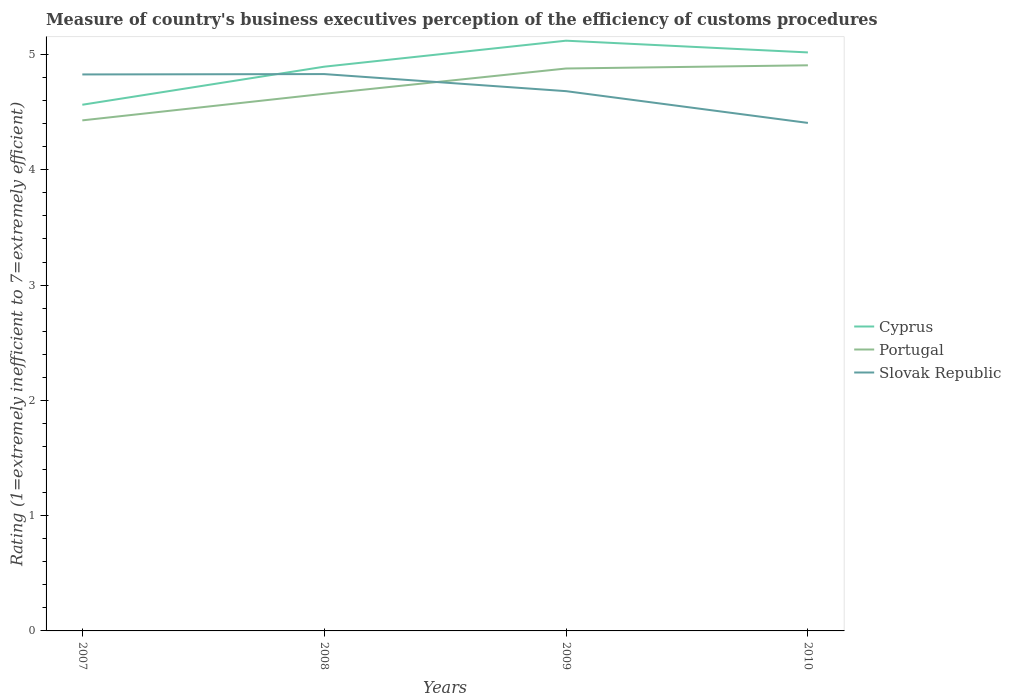How many different coloured lines are there?
Provide a short and direct response. 3. Does the line corresponding to Slovak Republic intersect with the line corresponding to Cyprus?
Your answer should be very brief. Yes. Is the number of lines equal to the number of legend labels?
Ensure brevity in your answer.  Yes. Across all years, what is the maximum rating of the efficiency of customs procedure in Cyprus?
Your answer should be compact. 4.56. In which year was the rating of the efficiency of customs procedure in Portugal maximum?
Ensure brevity in your answer.  2007. What is the total rating of the efficiency of customs procedure in Portugal in the graph?
Ensure brevity in your answer.  -0.45. What is the difference between the highest and the second highest rating of the efficiency of customs procedure in Portugal?
Offer a terse response. 0.48. How many lines are there?
Give a very brief answer. 3. How many years are there in the graph?
Your response must be concise. 4. What is the difference between two consecutive major ticks on the Y-axis?
Provide a short and direct response. 1. Does the graph contain any zero values?
Give a very brief answer. No. Does the graph contain grids?
Offer a very short reply. No. Where does the legend appear in the graph?
Your answer should be very brief. Center right. How many legend labels are there?
Provide a short and direct response. 3. What is the title of the graph?
Your answer should be compact. Measure of country's business executives perception of the efficiency of customs procedures. What is the label or title of the X-axis?
Your answer should be very brief. Years. What is the label or title of the Y-axis?
Provide a short and direct response. Rating (1=extremely inefficient to 7=extremely efficient). What is the Rating (1=extremely inefficient to 7=extremely efficient) in Cyprus in 2007?
Your answer should be very brief. 4.56. What is the Rating (1=extremely inefficient to 7=extremely efficient) of Portugal in 2007?
Your response must be concise. 4.43. What is the Rating (1=extremely inefficient to 7=extremely efficient) of Slovak Republic in 2007?
Provide a short and direct response. 4.83. What is the Rating (1=extremely inefficient to 7=extremely efficient) of Cyprus in 2008?
Ensure brevity in your answer.  4.89. What is the Rating (1=extremely inefficient to 7=extremely efficient) of Portugal in 2008?
Offer a very short reply. 4.66. What is the Rating (1=extremely inefficient to 7=extremely efficient) in Slovak Republic in 2008?
Give a very brief answer. 4.83. What is the Rating (1=extremely inefficient to 7=extremely efficient) of Cyprus in 2009?
Provide a short and direct response. 5.12. What is the Rating (1=extremely inefficient to 7=extremely efficient) of Portugal in 2009?
Offer a terse response. 4.88. What is the Rating (1=extremely inefficient to 7=extremely efficient) in Slovak Republic in 2009?
Make the answer very short. 4.68. What is the Rating (1=extremely inefficient to 7=extremely efficient) in Cyprus in 2010?
Your answer should be very brief. 5.02. What is the Rating (1=extremely inefficient to 7=extremely efficient) of Portugal in 2010?
Make the answer very short. 4.91. What is the Rating (1=extremely inefficient to 7=extremely efficient) of Slovak Republic in 2010?
Provide a succinct answer. 4.41. Across all years, what is the maximum Rating (1=extremely inefficient to 7=extremely efficient) in Cyprus?
Your answer should be very brief. 5.12. Across all years, what is the maximum Rating (1=extremely inefficient to 7=extremely efficient) in Portugal?
Your answer should be compact. 4.91. Across all years, what is the maximum Rating (1=extremely inefficient to 7=extremely efficient) in Slovak Republic?
Make the answer very short. 4.83. Across all years, what is the minimum Rating (1=extremely inefficient to 7=extremely efficient) of Cyprus?
Offer a very short reply. 4.56. Across all years, what is the minimum Rating (1=extremely inefficient to 7=extremely efficient) in Portugal?
Keep it short and to the point. 4.43. Across all years, what is the minimum Rating (1=extremely inefficient to 7=extremely efficient) in Slovak Republic?
Provide a short and direct response. 4.41. What is the total Rating (1=extremely inefficient to 7=extremely efficient) in Cyprus in the graph?
Provide a short and direct response. 19.6. What is the total Rating (1=extremely inefficient to 7=extremely efficient) of Portugal in the graph?
Give a very brief answer. 18.87. What is the total Rating (1=extremely inefficient to 7=extremely efficient) in Slovak Republic in the graph?
Give a very brief answer. 18.75. What is the difference between the Rating (1=extremely inefficient to 7=extremely efficient) of Cyprus in 2007 and that in 2008?
Your answer should be compact. -0.33. What is the difference between the Rating (1=extremely inefficient to 7=extremely efficient) in Portugal in 2007 and that in 2008?
Your answer should be compact. -0.23. What is the difference between the Rating (1=extremely inefficient to 7=extremely efficient) of Slovak Republic in 2007 and that in 2008?
Offer a terse response. -0. What is the difference between the Rating (1=extremely inefficient to 7=extremely efficient) of Cyprus in 2007 and that in 2009?
Provide a short and direct response. -0.56. What is the difference between the Rating (1=extremely inefficient to 7=extremely efficient) in Portugal in 2007 and that in 2009?
Provide a succinct answer. -0.45. What is the difference between the Rating (1=extremely inefficient to 7=extremely efficient) in Slovak Republic in 2007 and that in 2009?
Your response must be concise. 0.14. What is the difference between the Rating (1=extremely inefficient to 7=extremely efficient) in Cyprus in 2007 and that in 2010?
Your answer should be very brief. -0.45. What is the difference between the Rating (1=extremely inefficient to 7=extremely efficient) of Portugal in 2007 and that in 2010?
Offer a very short reply. -0.48. What is the difference between the Rating (1=extremely inefficient to 7=extremely efficient) in Slovak Republic in 2007 and that in 2010?
Your answer should be compact. 0.42. What is the difference between the Rating (1=extremely inefficient to 7=extremely efficient) of Cyprus in 2008 and that in 2009?
Give a very brief answer. -0.23. What is the difference between the Rating (1=extremely inefficient to 7=extremely efficient) of Portugal in 2008 and that in 2009?
Your answer should be compact. -0.22. What is the difference between the Rating (1=extremely inefficient to 7=extremely efficient) of Slovak Republic in 2008 and that in 2009?
Provide a succinct answer. 0.15. What is the difference between the Rating (1=extremely inefficient to 7=extremely efficient) in Cyprus in 2008 and that in 2010?
Offer a terse response. -0.12. What is the difference between the Rating (1=extremely inefficient to 7=extremely efficient) in Portugal in 2008 and that in 2010?
Offer a terse response. -0.25. What is the difference between the Rating (1=extremely inefficient to 7=extremely efficient) of Slovak Republic in 2008 and that in 2010?
Provide a short and direct response. 0.42. What is the difference between the Rating (1=extremely inefficient to 7=extremely efficient) in Cyprus in 2009 and that in 2010?
Your answer should be very brief. 0.1. What is the difference between the Rating (1=extremely inefficient to 7=extremely efficient) of Portugal in 2009 and that in 2010?
Give a very brief answer. -0.03. What is the difference between the Rating (1=extremely inefficient to 7=extremely efficient) of Slovak Republic in 2009 and that in 2010?
Ensure brevity in your answer.  0.28. What is the difference between the Rating (1=extremely inefficient to 7=extremely efficient) in Cyprus in 2007 and the Rating (1=extremely inefficient to 7=extremely efficient) in Portugal in 2008?
Provide a short and direct response. -0.09. What is the difference between the Rating (1=extremely inefficient to 7=extremely efficient) of Cyprus in 2007 and the Rating (1=extremely inefficient to 7=extremely efficient) of Slovak Republic in 2008?
Your answer should be very brief. -0.27. What is the difference between the Rating (1=extremely inefficient to 7=extremely efficient) of Portugal in 2007 and the Rating (1=extremely inefficient to 7=extremely efficient) of Slovak Republic in 2008?
Ensure brevity in your answer.  -0.4. What is the difference between the Rating (1=extremely inefficient to 7=extremely efficient) of Cyprus in 2007 and the Rating (1=extremely inefficient to 7=extremely efficient) of Portugal in 2009?
Ensure brevity in your answer.  -0.31. What is the difference between the Rating (1=extremely inefficient to 7=extremely efficient) in Cyprus in 2007 and the Rating (1=extremely inefficient to 7=extremely efficient) in Slovak Republic in 2009?
Ensure brevity in your answer.  -0.12. What is the difference between the Rating (1=extremely inefficient to 7=extremely efficient) of Portugal in 2007 and the Rating (1=extremely inefficient to 7=extremely efficient) of Slovak Republic in 2009?
Keep it short and to the point. -0.25. What is the difference between the Rating (1=extremely inefficient to 7=extremely efficient) in Cyprus in 2007 and the Rating (1=extremely inefficient to 7=extremely efficient) in Portugal in 2010?
Your answer should be compact. -0.34. What is the difference between the Rating (1=extremely inefficient to 7=extremely efficient) in Cyprus in 2007 and the Rating (1=extremely inefficient to 7=extremely efficient) in Slovak Republic in 2010?
Ensure brevity in your answer.  0.16. What is the difference between the Rating (1=extremely inefficient to 7=extremely efficient) in Portugal in 2007 and the Rating (1=extremely inefficient to 7=extremely efficient) in Slovak Republic in 2010?
Your response must be concise. 0.02. What is the difference between the Rating (1=extremely inefficient to 7=extremely efficient) of Cyprus in 2008 and the Rating (1=extremely inefficient to 7=extremely efficient) of Portugal in 2009?
Keep it short and to the point. 0.02. What is the difference between the Rating (1=extremely inefficient to 7=extremely efficient) in Cyprus in 2008 and the Rating (1=extremely inefficient to 7=extremely efficient) in Slovak Republic in 2009?
Keep it short and to the point. 0.21. What is the difference between the Rating (1=extremely inefficient to 7=extremely efficient) of Portugal in 2008 and the Rating (1=extremely inefficient to 7=extremely efficient) of Slovak Republic in 2009?
Offer a terse response. -0.02. What is the difference between the Rating (1=extremely inefficient to 7=extremely efficient) of Cyprus in 2008 and the Rating (1=extremely inefficient to 7=extremely efficient) of Portugal in 2010?
Ensure brevity in your answer.  -0.01. What is the difference between the Rating (1=extremely inefficient to 7=extremely efficient) in Cyprus in 2008 and the Rating (1=extremely inefficient to 7=extremely efficient) in Slovak Republic in 2010?
Keep it short and to the point. 0.49. What is the difference between the Rating (1=extremely inefficient to 7=extremely efficient) of Portugal in 2008 and the Rating (1=extremely inefficient to 7=extremely efficient) of Slovak Republic in 2010?
Make the answer very short. 0.25. What is the difference between the Rating (1=extremely inefficient to 7=extremely efficient) in Cyprus in 2009 and the Rating (1=extremely inefficient to 7=extremely efficient) in Portugal in 2010?
Make the answer very short. 0.21. What is the difference between the Rating (1=extremely inefficient to 7=extremely efficient) of Cyprus in 2009 and the Rating (1=extremely inefficient to 7=extremely efficient) of Slovak Republic in 2010?
Offer a very short reply. 0.71. What is the difference between the Rating (1=extremely inefficient to 7=extremely efficient) of Portugal in 2009 and the Rating (1=extremely inefficient to 7=extremely efficient) of Slovak Republic in 2010?
Provide a succinct answer. 0.47. What is the average Rating (1=extremely inefficient to 7=extremely efficient) of Cyprus per year?
Your answer should be compact. 4.9. What is the average Rating (1=extremely inefficient to 7=extremely efficient) of Portugal per year?
Ensure brevity in your answer.  4.72. What is the average Rating (1=extremely inefficient to 7=extremely efficient) in Slovak Republic per year?
Offer a terse response. 4.69. In the year 2007, what is the difference between the Rating (1=extremely inefficient to 7=extremely efficient) of Cyprus and Rating (1=extremely inefficient to 7=extremely efficient) of Portugal?
Your response must be concise. 0.14. In the year 2007, what is the difference between the Rating (1=extremely inefficient to 7=extremely efficient) in Cyprus and Rating (1=extremely inefficient to 7=extremely efficient) in Slovak Republic?
Your answer should be compact. -0.26. In the year 2007, what is the difference between the Rating (1=extremely inefficient to 7=extremely efficient) of Portugal and Rating (1=extremely inefficient to 7=extremely efficient) of Slovak Republic?
Your answer should be very brief. -0.4. In the year 2008, what is the difference between the Rating (1=extremely inefficient to 7=extremely efficient) in Cyprus and Rating (1=extremely inefficient to 7=extremely efficient) in Portugal?
Your answer should be very brief. 0.24. In the year 2008, what is the difference between the Rating (1=extremely inefficient to 7=extremely efficient) in Cyprus and Rating (1=extremely inefficient to 7=extremely efficient) in Slovak Republic?
Your answer should be very brief. 0.06. In the year 2008, what is the difference between the Rating (1=extremely inefficient to 7=extremely efficient) of Portugal and Rating (1=extremely inefficient to 7=extremely efficient) of Slovak Republic?
Your answer should be very brief. -0.17. In the year 2009, what is the difference between the Rating (1=extremely inefficient to 7=extremely efficient) in Cyprus and Rating (1=extremely inefficient to 7=extremely efficient) in Portugal?
Provide a succinct answer. 0.24. In the year 2009, what is the difference between the Rating (1=extremely inefficient to 7=extremely efficient) in Cyprus and Rating (1=extremely inefficient to 7=extremely efficient) in Slovak Republic?
Provide a short and direct response. 0.44. In the year 2009, what is the difference between the Rating (1=extremely inefficient to 7=extremely efficient) of Portugal and Rating (1=extremely inefficient to 7=extremely efficient) of Slovak Republic?
Keep it short and to the point. 0.2. In the year 2010, what is the difference between the Rating (1=extremely inefficient to 7=extremely efficient) in Cyprus and Rating (1=extremely inefficient to 7=extremely efficient) in Portugal?
Your response must be concise. 0.11. In the year 2010, what is the difference between the Rating (1=extremely inefficient to 7=extremely efficient) in Cyprus and Rating (1=extremely inefficient to 7=extremely efficient) in Slovak Republic?
Make the answer very short. 0.61. In the year 2010, what is the difference between the Rating (1=extremely inefficient to 7=extremely efficient) of Portugal and Rating (1=extremely inefficient to 7=extremely efficient) of Slovak Republic?
Offer a terse response. 0.5. What is the ratio of the Rating (1=extremely inefficient to 7=extremely efficient) in Cyprus in 2007 to that in 2008?
Offer a terse response. 0.93. What is the ratio of the Rating (1=extremely inefficient to 7=extremely efficient) of Portugal in 2007 to that in 2008?
Your response must be concise. 0.95. What is the ratio of the Rating (1=extremely inefficient to 7=extremely efficient) of Slovak Republic in 2007 to that in 2008?
Offer a very short reply. 1. What is the ratio of the Rating (1=extremely inefficient to 7=extremely efficient) of Cyprus in 2007 to that in 2009?
Your response must be concise. 0.89. What is the ratio of the Rating (1=extremely inefficient to 7=extremely efficient) of Portugal in 2007 to that in 2009?
Make the answer very short. 0.91. What is the ratio of the Rating (1=extremely inefficient to 7=extremely efficient) in Slovak Republic in 2007 to that in 2009?
Your response must be concise. 1.03. What is the ratio of the Rating (1=extremely inefficient to 7=extremely efficient) of Cyprus in 2007 to that in 2010?
Your response must be concise. 0.91. What is the ratio of the Rating (1=extremely inefficient to 7=extremely efficient) in Portugal in 2007 to that in 2010?
Make the answer very short. 0.9. What is the ratio of the Rating (1=extremely inefficient to 7=extremely efficient) of Slovak Republic in 2007 to that in 2010?
Provide a succinct answer. 1.1. What is the ratio of the Rating (1=extremely inefficient to 7=extremely efficient) in Cyprus in 2008 to that in 2009?
Provide a short and direct response. 0.96. What is the ratio of the Rating (1=extremely inefficient to 7=extremely efficient) of Portugal in 2008 to that in 2009?
Make the answer very short. 0.95. What is the ratio of the Rating (1=extremely inefficient to 7=extremely efficient) in Slovak Republic in 2008 to that in 2009?
Provide a succinct answer. 1.03. What is the ratio of the Rating (1=extremely inefficient to 7=extremely efficient) of Cyprus in 2008 to that in 2010?
Your answer should be very brief. 0.98. What is the ratio of the Rating (1=extremely inefficient to 7=extremely efficient) of Portugal in 2008 to that in 2010?
Make the answer very short. 0.95. What is the ratio of the Rating (1=extremely inefficient to 7=extremely efficient) in Slovak Republic in 2008 to that in 2010?
Give a very brief answer. 1.1. What is the ratio of the Rating (1=extremely inefficient to 7=extremely efficient) of Cyprus in 2009 to that in 2010?
Your answer should be very brief. 1.02. What is the ratio of the Rating (1=extremely inefficient to 7=extremely efficient) in Slovak Republic in 2009 to that in 2010?
Make the answer very short. 1.06. What is the difference between the highest and the second highest Rating (1=extremely inefficient to 7=extremely efficient) of Cyprus?
Your answer should be very brief. 0.1. What is the difference between the highest and the second highest Rating (1=extremely inefficient to 7=extremely efficient) of Portugal?
Ensure brevity in your answer.  0.03. What is the difference between the highest and the second highest Rating (1=extremely inefficient to 7=extremely efficient) in Slovak Republic?
Make the answer very short. 0. What is the difference between the highest and the lowest Rating (1=extremely inefficient to 7=extremely efficient) of Cyprus?
Your answer should be compact. 0.56. What is the difference between the highest and the lowest Rating (1=extremely inefficient to 7=extremely efficient) in Portugal?
Provide a succinct answer. 0.48. What is the difference between the highest and the lowest Rating (1=extremely inefficient to 7=extremely efficient) of Slovak Republic?
Keep it short and to the point. 0.42. 